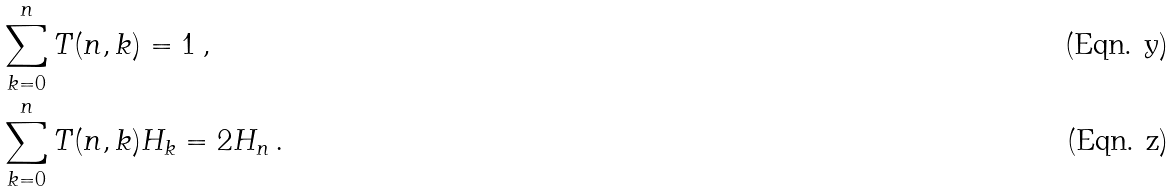<formula> <loc_0><loc_0><loc_500><loc_500>& \sum _ { k = 0 } ^ { n } T ( n , k ) = 1 \, , \\ & \sum _ { k = 0 } ^ { n } T ( n , k ) H _ { k } = 2 H _ { n } \, .</formula> 